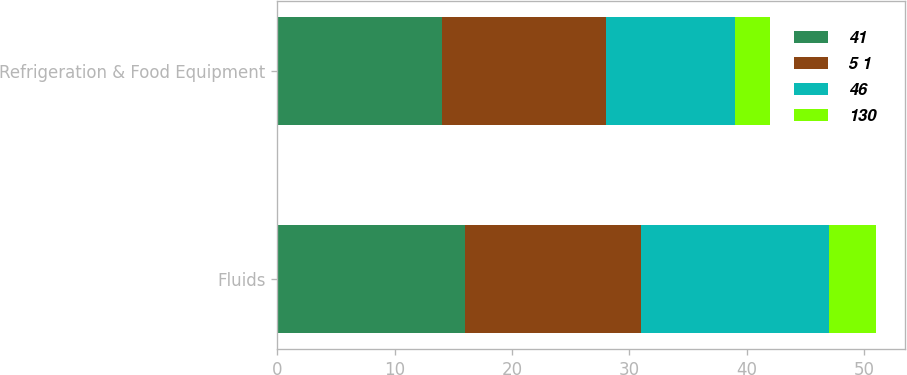Convert chart to OTSL. <chart><loc_0><loc_0><loc_500><loc_500><stacked_bar_chart><ecel><fcel>Fluids<fcel>Refrigeration & Food Equipment<nl><fcel>41<fcel>16<fcel>14<nl><fcel>5 1<fcel>15<fcel>14<nl><fcel>46<fcel>16<fcel>11<nl><fcel>130<fcel>4<fcel>3<nl></chart> 